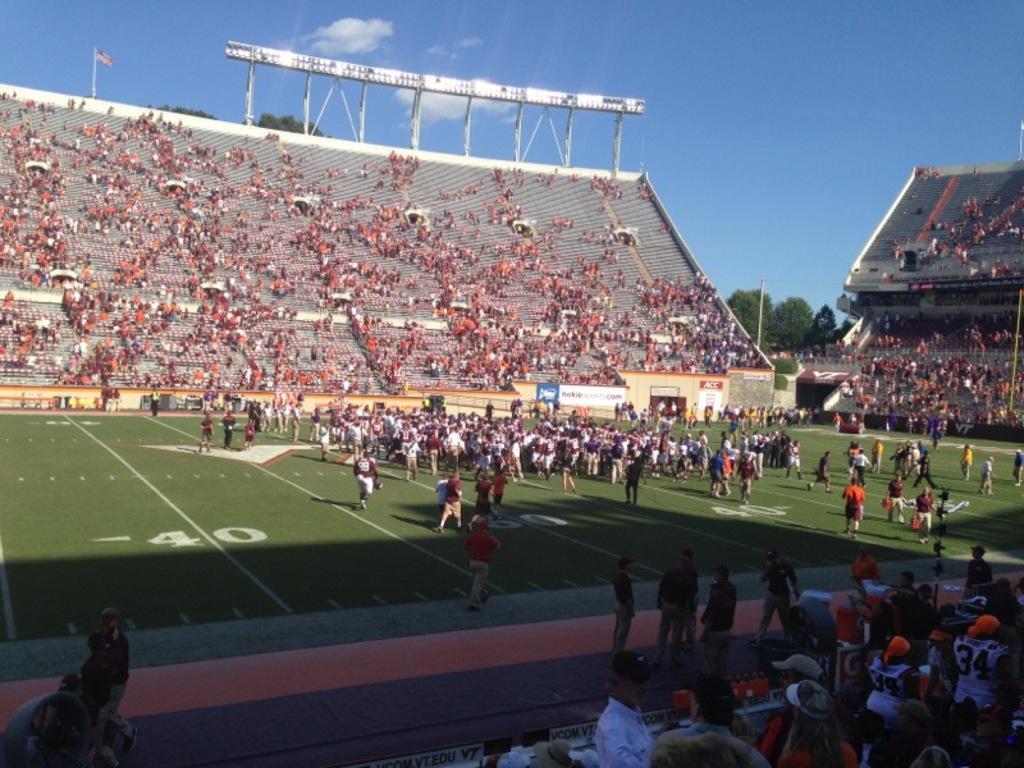Describe this image in one or two sentences. This is the picture of a stadium. In this image there are group of people standing. At the back there are boards on the wall and there is text on the boards and there are trees and there is a flag and pole. At the top there is sky and there are clouds. At the bottom there might be grass. 